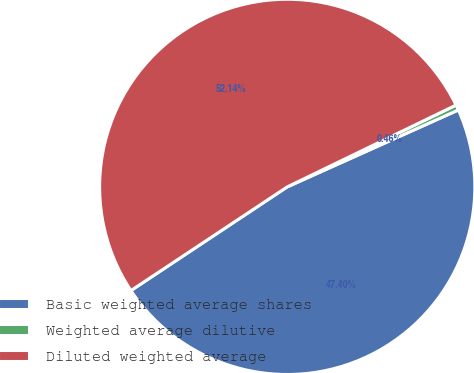<chart> <loc_0><loc_0><loc_500><loc_500><pie_chart><fcel>Basic weighted average shares<fcel>Weighted average dilutive<fcel>Diluted weighted average<nl><fcel>47.4%<fcel>0.46%<fcel>52.14%<nl></chart> 